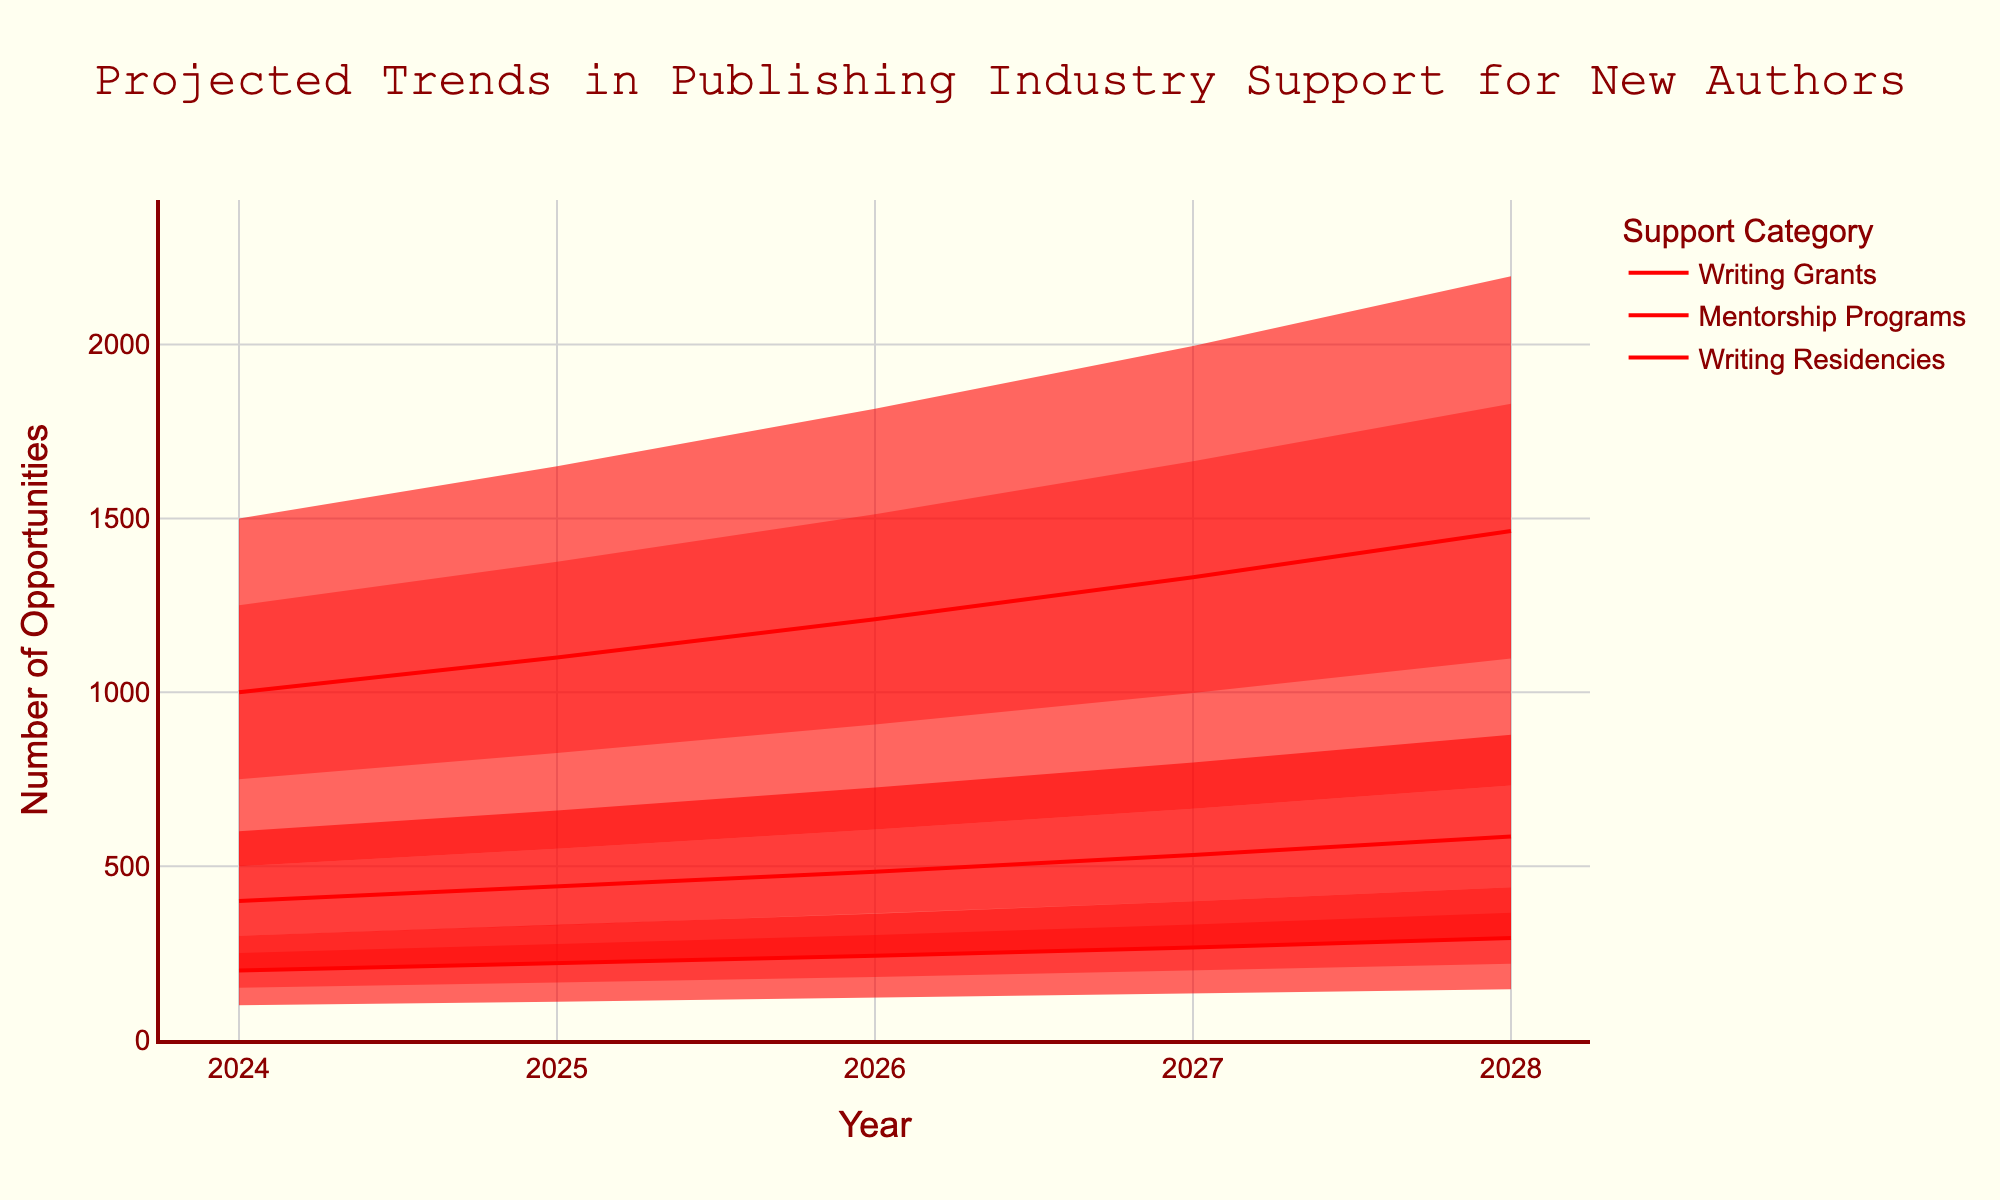What are the projected high values for Writing Grants in 2026? Look for the high value for Writing Grants in 2026 in the chart. The data shows 1815.
Answer: 1815 How many years are displayed in the chart? Count the distinct years on the x-axis. There are 5 years: 2024, 2025, 2026, 2027, and 2028.
Answer: 5 Which support category has the lowest projected mid value in 2027? Compare the mid values of the three categories in 2027. Writing Residencies have the lowest with a mid value of 266.
Answer: Writing Residencies What's the difference between the high and low projected values for Mentorship Programs in 2028? Subtract the low value from the high value for Mentorship Programs in 2028. High is 878, and low is 293. The difference is 878 - 293 = 585.
Answer: 585 What is the general trend for Writing Grants over the 5-year period? The mid-projected values for Writing Grants increase each year from 1000 in 2024 to 1464 in 2028, indicating an upward trend.
Answer: Upward trend Which year shows the highest high value for Writing Residencies? Check the highest high value for Writing Residencies across all years, which is 2028 with 439.
Answer: 2028 How does the projected increase in Mid-High values for Writing Grants from 2024 to 2025 compare to the increase from 2025 to 2026? Calculate the differences between the Mid-High values for Writing Grants from 2024 to 2025 (1250 to 1375) and 2025 to 2026 (1375 to 1512). The increase from 2024 to 2025 is 125, and from 2025 to 2026 is 137.
Answer: 137 is greater than 125 Which category shows the most significant expected increase in support from 2024 to 2028? Compare the projected increases in Mid values for each category from 2024 to 2028. Writing Grants show the largest increase from 1000 in 2024 to 1464 in 2028, which is 464.
Answer: Writing Grants 